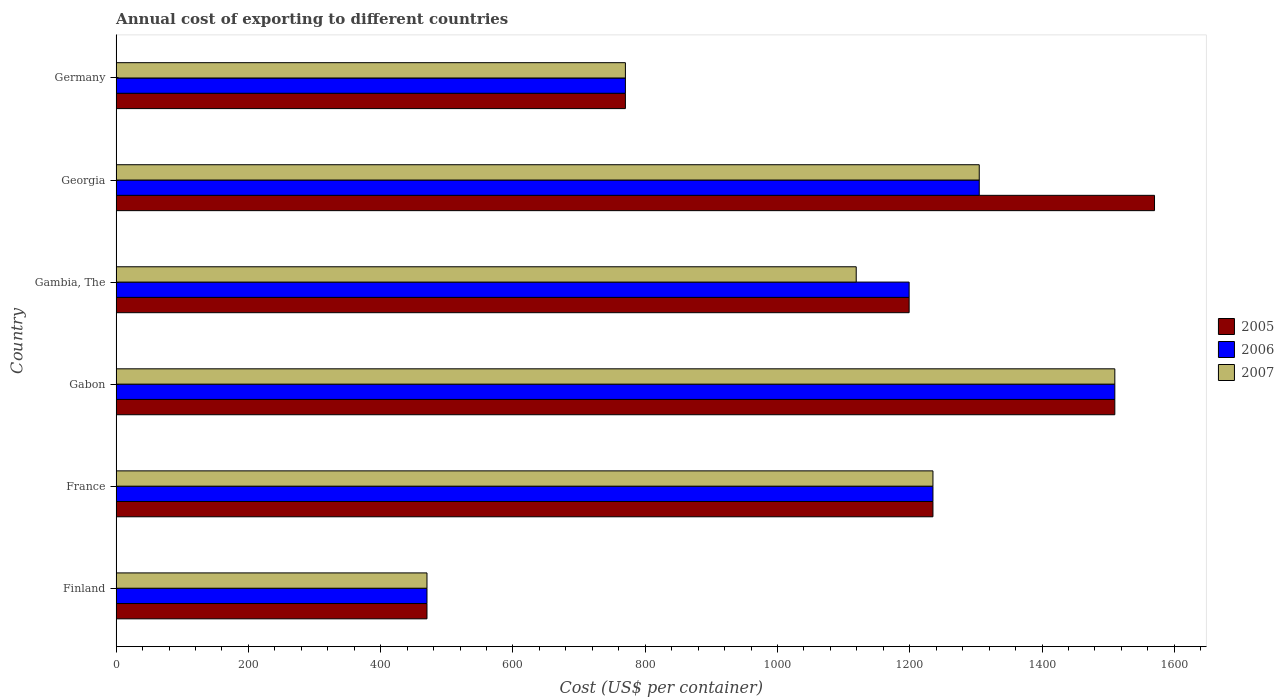How many groups of bars are there?
Give a very brief answer. 6. What is the label of the 2nd group of bars from the top?
Your answer should be very brief. Georgia. What is the total annual cost of exporting in 2005 in Gabon?
Offer a very short reply. 1510. Across all countries, what is the maximum total annual cost of exporting in 2006?
Your answer should be very brief. 1510. Across all countries, what is the minimum total annual cost of exporting in 2007?
Provide a succinct answer. 470. In which country was the total annual cost of exporting in 2007 maximum?
Make the answer very short. Gabon. What is the total total annual cost of exporting in 2007 in the graph?
Provide a short and direct response. 6409. What is the difference between the total annual cost of exporting in 2007 in Gabon and that in Georgia?
Give a very brief answer. 205. What is the difference between the total annual cost of exporting in 2005 in Gambia, The and the total annual cost of exporting in 2006 in Germany?
Your answer should be very brief. 429. What is the average total annual cost of exporting in 2007 per country?
Provide a short and direct response. 1068.17. What is the difference between the total annual cost of exporting in 2007 and total annual cost of exporting in 2006 in Germany?
Give a very brief answer. 0. What is the ratio of the total annual cost of exporting in 2007 in France to that in Germany?
Keep it short and to the point. 1.6. Is the total annual cost of exporting in 2007 in Gabon less than that in Germany?
Offer a very short reply. No. What is the difference between the highest and the second highest total annual cost of exporting in 2006?
Your answer should be very brief. 205. What is the difference between the highest and the lowest total annual cost of exporting in 2007?
Keep it short and to the point. 1040. Is the sum of the total annual cost of exporting in 2007 in France and Georgia greater than the maximum total annual cost of exporting in 2006 across all countries?
Offer a terse response. Yes. What does the 1st bar from the top in Finland represents?
Give a very brief answer. 2007. How many bars are there?
Provide a succinct answer. 18. Are all the bars in the graph horizontal?
Give a very brief answer. Yes. Are the values on the major ticks of X-axis written in scientific E-notation?
Keep it short and to the point. No. Does the graph contain any zero values?
Provide a short and direct response. No. How many legend labels are there?
Give a very brief answer. 3. What is the title of the graph?
Provide a succinct answer. Annual cost of exporting to different countries. What is the label or title of the X-axis?
Ensure brevity in your answer.  Cost (US$ per container). What is the label or title of the Y-axis?
Offer a terse response. Country. What is the Cost (US$ per container) of 2005 in Finland?
Keep it short and to the point. 470. What is the Cost (US$ per container) of 2006 in Finland?
Make the answer very short. 470. What is the Cost (US$ per container) of 2007 in Finland?
Ensure brevity in your answer.  470. What is the Cost (US$ per container) of 2005 in France?
Your answer should be compact. 1235. What is the Cost (US$ per container) of 2006 in France?
Provide a succinct answer. 1235. What is the Cost (US$ per container) of 2007 in France?
Offer a very short reply. 1235. What is the Cost (US$ per container) of 2005 in Gabon?
Your answer should be very brief. 1510. What is the Cost (US$ per container) of 2006 in Gabon?
Your answer should be compact. 1510. What is the Cost (US$ per container) of 2007 in Gabon?
Offer a terse response. 1510. What is the Cost (US$ per container) in 2005 in Gambia, The?
Offer a terse response. 1199. What is the Cost (US$ per container) in 2006 in Gambia, The?
Ensure brevity in your answer.  1199. What is the Cost (US$ per container) of 2007 in Gambia, The?
Your response must be concise. 1119. What is the Cost (US$ per container) in 2005 in Georgia?
Offer a terse response. 1570. What is the Cost (US$ per container) in 2006 in Georgia?
Offer a terse response. 1305. What is the Cost (US$ per container) of 2007 in Georgia?
Keep it short and to the point. 1305. What is the Cost (US$ per container) of 2005 in Germany?
Provide a short and direct response. 770. What is the Cost (US$ per container) of 2006 in Germany?
Your answer should be compact. 770. What is the Cost (US$ per container) in 2007 in Germany?
Your answer should be very brief. 770. Across all countries, what is the maximum Cost (US$ per container) in 2005?
Ensure brevity in your answer.  1570. Across all countries, what is the maximum Cost (US$ per container) of 2006?
Keep it short and to the point. 1510. Across all countries, what is the maximum Cost (US$ per container) in 2007?
Make the answer very short. 1510. Across all countries, what is the minimum Cost (US$ per container) in 2005?
Make the answer very short. 470. Across all countries, what is the minimum Cost (US$ per container) of 2006?
Your response must be concise. 470. Across all countries, what is the minimum Cost (US$ per container) of 2007?
Your answer should be very brief. 470. What is the total Cost (US$ per container) in 2005 in the graph?
Offer a terse response. 6754. What is the total Cost (US$ per container) of 2006 in the graph?
Ensure brevity in your answer.  6489. What is the total Cost (US$ per container) of 2007 in the graph?
Ensure brevity in your answer.  6409. What is the difference between the Cost (US$ per container) in 2005 in Finland and that in France?
Your response must be concise. -765. What is the difference between the Cost (US$ per container) in 2006 in Finland and that in France?
Make the answer very short. -765. What is the difference between the Cost (US$ per container) of 2007 in Finland and that in France?
Offer a very short reply. -765. What is the difference between the Cost (US$ per container) in 2005 in Finland and that in Gabon?
Provide a short and direct response. -1040. What is the difference between the Cost (US$ per container) of 2006 in Finland and that in Gabon?
Offer a terse response. -1040. What is the difference between the Cost (US$ per container) of 2007 in Finland and that in Gabon?
Keep it short and to the point. -1040. What is the difference between the Cost (US$ per container) of 2005 in Finland and that in Gambia, The?
Offer a very short reply. -729. What is the difference between the Cost (US$ per container) of 2006 in Finland and that in Gambia, The?
Your answer should be compact. -729. What is the difference between the Cost (US$ per container) in 2007 in Finland and that in Gambia, The?
Provide a succinct answer. -649. What is the difference between the Cost (US$ per container) in 2005 in Finland and that in Georgia?
Give a very brief answer. -1100. What is the difference between the Cost (US$ per container) of 2006 in Finland and that in Georgia?
Provide a short and direct response. -835. What is the difference between the Cost (US$ per container) in 2007 in Finland and that in Georgia?
Your response must be concise. -835. What is the difference between the Cost (US$ per container) of 2005 in Finland and that in Germany?
Your answer should be compact. -300. What is the difference between the Cost (US$ per container) of 2006 in Finland and that in Germany?
Give a very brief answer. -300. What is the difference between the Cost (US$ per container) in 2007 in Finland and that in Germany?
Give a very brief answer. -300. What is the difference between the Cost (US$ per container) in 2005 in France and that in Gabon?
Ensure brevity in your answer.  -275. What is the difference between the Cost (US$ per container) of 2006 in France and that in Gabon?
Your answer should be very brief. -275. What is the difference between the Cost (US$ per container) of 2007 in France and that in Gabon?
Give a very brief answer. -275. What is the difference between the Cost (US$ per container) in 2006 in France and that in Gambia, The?
Your answer should be very brief. 36. What is the difference between the Cost (US$ per container) in 2007 in France and that in Gambia, The?
Give a very brief answer. 116. What is the difference between the Cost (US$ per container) in 2005 in France and that in Georgia?
Offer a terse response. -335. What is the difference between the Cost (US$ per container) of 2006 in France and that in Georgia?
Make the answer very short. -70. What is the difference between the Cost (US$ per container) in 2007 in France and that in Georgia?
Your answer should be very brief. -70. What is the difference between the Cost (US$ per container) in 2005 in France and that in Germany?
Offer a terse response. 465. What is the difference between the Cost (US$ per container) in 2006 in France and that in Germany?
Your answer should be compact. 465. What is the difference between the Cost (US$ per container) of 2007 in France and that in Germany?
Ensure brevity in your answer.  465. What is the difference between the Cost (US$ per container) in 2005 in Gabon and that in Gambia, The?
Make the answer very short. 311. What is the difference between the Cost (US$ per container) in 2006 in Gabon and that in Gambia, The?
Your answer should be very brief. 311. What is the difference between the Cost (US$ per container) in 2007 in Gabon and that in Gambia, The?
Your answer should be very brief. 391. What is the difference between the Cost (US$ per container) in 2005 in Gabon and that in Georgia?
Provide a succinct answer. -60. What is the difference between the Cost (US$ per container) of 2006 in Gabon and that in Georgia?
Provide a short and direct response. 205. What is the difference between the Cost (US$ per container) of 2007 in Gabon and that in Georgia?
Offer a terse response. 205. What is the difference between the Cost (US$ per container) of 2005 in Gabon and that in Germany?
Your answer should be very brief. 740. What is the difference between the Cost (US$ per container) of 2006 in Gabon and that in Germany?
Give a very brief answer. 740. What is the difference between the Cost (US$ per container) in 2007 in Gabon and that in Germany?
Your answer should be very brief. 740. What is the difference between the Cost (US$ per container) in 2005 in Gambia, The and that in Georgia?
Ensure brevity in your answer.  -371. What is the difference between the Cost (US$ per container) of 2006 in Gambia, The and that in Georgia?
Give a very brief answer. -106. What is the difference between the Cost (US$ per container) of 2007 in Gambia, The and that in Georgia?
Provide a succinct answer. -186. What is the difference between the Cost (US$ per container) in 2005 in Gambia, The and that in Germany?
Offer a very short reply. 429. What is the difference between the Cost (US$ per container) of 2006 in Gambia, The and that in Germany?
Your response must be concise. 429. What is the difference between the Cost (US$ per container) of 2007 in Gambia, The and that in Germany?
Give a very brief answer. 349. What is the difference between the Cost (US$ per container) in 2005 in Georgia and that in Germany?
Keep it short and to the point. 800. What is the difference between the Cost (US$ per container) in 2006 in Georgia and that in Germany?
Keep it short and to the point. 535. What is the difference between the Cost (US$ per container) of 2007 in Georgia and that in Germany?
Offer a very short reply. 535. What is the difference between the Cost (US$ per container) in 2005 in Finland and the Cost (US$ per container) in 2006 in France?
Your answer should be very brief. -765. What is the difference between the Cost (US$ per container) in 2005 in Finland and the Cost (US$ per container) in 2007 in France?
Give a very brief answer. -765. What is the difference between the Cost (US$ per container) of 2006 in Finland and the Cost (US$ per container) of 2007 in France?
Give a very brief answer. -765. What is the difference between the Cost (US$ per container) in 2005 in Finland and the Cost (US$ per container) in 2006 in Gabon?
Provide a succinct answer. -1040. What is the difference between the Cost (US$ per container) in 2005 in Finland and the Cost (US$ per container) in 2007 in Gabon?
Your answer should be compact. -1040. What is the difference between the Cost (US$ per container) of 2006 in Finland and the Cost (US$ per container) of 2007 in Gabon?
Provide a succinct answer. -1040. What is the difference between the Cost (US$ per container) of 2005 in Finland and the Cost (US$ per container) of 2006 in Gambia, The?
Provide a succinct answer. -729. What is the difference between the Cost (US$ per container) in 2005 in Finland and the Cost (US$ per container) in 2007 in Gambia, The?
Your answer should be very brief. -649. What is the difference between the Cost (US$ per container) of 2006 in Finland and the Cost (US$ per container) of 2007 in Gambia, The?
Give a very brief answer. -649. What is the difference between the Cost (US$ per container) in 2005 in Finland and the Cost (US$ per container) in 2006 in Georgia?
Your answer should be very brief. -835. What is the difference between the Cost (US$ per container) of 2005 in Finland and the Cost (US$ per container) of 2007 in Georgia?
Offer a very short reply. -835. What is the difference between the Cost (US$ per container) in 2006 in Finland and the Cost (US$ per container) in 2007 in Georgia?
Ensure brevity in your answer.  -835. What is the difference between the Cost (US$ per container) in 2005 in Finland and the Cost (US$ per container) in 2006 in Germany?
Provide a short and direct response. -300. What is the difference between the Cost (US$ per container) of 2005 in Finland and the Cost (US$ per container) of 2007 in Germany?
Your answer should be very brief. -300. What is the difference between the Cost (US$ per container) in 2006 in Finland and the Cost (US$ per container) in 2007 in Germany?
Your answer should be compact. -300. What is the difference between the Cost (US$ per container) in 2005 in France and the Cost (US$ per container) in 2006 in Gabon?
Provide a succinct answer. -275. What is the difference between the Cost (US$ per container) in 2005 in France and the Cost (US$ per container) in 2007 in Gabon?
Make the answer very short. -275. What is the difference between the Cost (US$ per container) of 2006 in France and the Cost (US$ per container) of 2007 in Gabon?
Give a very brief answer. -275. What is the difference between the Cost (US$ per container) of 2005 in France and the Cost (US$ per container) of 2006 in Gambia, The?
Give a very brief answer. 36. What is the difference between the Cost (US$ per container) of 2005 in France and the Cost (US$ per container) of 2007 in Gambia, The?
Provide a succinct answer. 116. What is the difference between the Cost (US$ per container) of 2006 in France and the Cost (US$ per container) of 2007 in Gambia, The?
Offer a very short reply. 116. What is the difference between the Cost (US$ per container) in 2005 in France and the Cost (US$ per container) in 2006 in Georgia?
Provide a succinct answer. -70. What is the difference between the Cost (US$ per container) in 2005 in France and the Cost (US$ per container) in 2007 in Georgia?
Your response must be concise. -70. What is the difference between the Cost (US$ per container) in 2006 in France and the Cost (US$ per container) in 2007 in Georgia?
Ensure brevity in your answer.  -70. What is the difference between the Cost (US$ per container) of 2005 in France and the Cost (US$ per container) of 2006 in Germany?
Provide a short and direct response. 465. What is the difference between the Cost (US$ per container) of 2005 in France and the Cost (US$ per container) of 2007 in Germany?
Give a very brief answer. 465. What is the difference between the Cost (US$ per container) in 2006 in France and the Cost (US$ per container) in 2007 in Germany?
Keep it short and to the point. 465. What is the difference between the Cost (US$ per container) in 2005 in Gabon and the Cost (US$ per container) in 2006 in Gambia, The?
Give a very brief answer. 311. What is the difference between the Cost (US$ per container) of 2005 in Gabon and the Cost (US$ per container) of 2007 in Gambia, The?
Your answer should be compact. 391. What is the difference between the Cost (US$ per container) in 2006 in Gabon and the Cost (US$ per container) in 2007 in Gambia, The?
Offer a terse response. 391. What is the difference between the Cost (US$ per container) of 2005 in Gabon and the Cost (US$ per container) of 2006 in Georgia?
Offer a terse response. 205. What is the difference between the Cost (US$ per container) in 2005 in Gabon and the Cost (US$ per container) in 2007 in Georgia?
Your answer should be very brief. 205. What is the difference between the Cost (US$ per container) in 2006 in Gabon and the Cost (US$ per container) in 2007 in Georgia?
Your answer should be compact. 205. What is the difference between the Cost (US$ per container) of 2005 in Gabon and the Cost (US$ per container) of 2006 in Germany?
Keep it short and to the point. 740. What is the difference between the Cost (US$ per container) in 2005 in Gabon and the Cost (US$ per container) in 2007 in Germany?
Your response must be concise. 740. What is the difference between the Cost (US$ per container) in 2006 in Gabon and the Cost (US$ per container) in 2007 in Germany?
Your answer should be compact. 740. What is the difference between the Cost (US$ per container) in 2005 in Gambia, The and the Cost (US$ per container) in 2006 in Georgia?
Keep it short and to the point. -106. What is the difference between the Cost (US$ per container) in 2005 in Gambia, The and the Cost (US$ per container) in 2007 in Georgia?
Ensure brevity in your answer.  -106. What is the difference between the Cost (US$ per container) of 2006 in Gambia, The and the Cost (US$ per container) of 2007 in Georgia?
Give a very brief answer. -106. What is the difference between the Cost (US$ per container) of 2005 in Gambia, The and the Cost (US$ per container) of 2006 in Germany?
Offer a terse response. 429. What is the difference between the Cost (US$ per container) in 2005 in Gambia, The and the Cost (US$ per container) in 2007 in Germany?
Keep it short and to the point. 429. What is the difference between the Cost (US$ per container) in 2006 in Gambia, The and the Cost (US$ per container) in 2007 in Germany?
Your answer should be compact. 429. What is the difference between the Cost (US$ per container) of 2005 in Georgia and the Cost (US$ per container) of 2006 in Germany?
Offer a terse response. 800. What is the difference between the Cost (US$ per container) in 2005 in Georgia and the Cost (US$ per container) in 2007 in Germany?
Offer a very short reply. 800. What is the difference between the Cost (US$ per container) of 2006 in Georgia and the Cost (US$ per container) of 2007 in Germany?
Ensure brevity in your answer.  535. What is the average Cost (US$ per container) in 2005 per country?
Provide a succinct answer. 1125.67. What is the average Cost (US$ per container) in 2006 per country?
Your answer should be compact. 1081.5. What is the average Cost (US$ per container) in 2007 per country?
Ensure brevity in your answer.  1068.17. What is the difference between the Cost (US$ per container) in 2005 and Cost (US$ per container) in 2006 in Finland?
Give a very brief answer. 0. What is the difference between the Cost (US$ per container) of 2005 and Cost (US$ per container) of 2007 in Finland?
Provide a short and direct response. 0. What is the difference between the Cost (US$ per container) of 2005 and Cost (US$ per container) of 2006 in France?
Provide a short and direct response. 0. What is the difference between the Cost (US$ per container) in 2005 and Cost (US$ per container) in 2007 in Gabon?
Provide a short and direct response. 0. What is the difference between the Cost (US$ per container) of 2006 and Cost (US$ per container) of 2007 in Gabon?
Offer a very short reply. 0. What is the difference between the Cost (US$ per container) in 2005 and Cost (US$ per container) in 2006 in Gambia, The?
Offer a very short reply. 0. What is the difference between the Cost (US$ per container) in 2006 and Cost (US$ per container) in 2007 in Gambia, The?
Ensure brevity in your answer.  80. What is the difference between the Cost (US$ per container) in 2005 and Cost (US$ per container) in 2006 in Georgia?
Your response must be concise. 265. What is the difference between the Cost (US$ per container) of 2005 and Cost (US$ per container) of 2007 in Georgia?
Offer a terse response. 265. What is the difference between the Cost (US$ per container) of 2006 and Cost (US$ per container) of 2007 in Georgia?
Provide a succinct answer. 0. What is the difference between the Cost (US$ per container) in 2005 and Cost (US$ per container) in 2006 in Germany?
Make the answer very short. 0. What is the difference between the Cost (US$ per container) in 2005 and Cost (US$ per container) in 2007 in Germany?
Offer a terse response. 0. What is the ratio of the Cost (US$ per container) in 2005 in Finland to that in France?
Your answer should be compact. 0.38. What is the ratio of the Cost (US$ per container) in 2006 in Finland to that in France?
Your response must be concise. 0.38. What is the ratio of the Cost (US$ per container) in 2007 in Finland to that in France?
Offer a terse response. 0.38. What is the ratio of the Cost (US$ per container) in 2005 in Finland to that in Gabon?
Keep it short and to the point. 0.31. What is the ratio of the Cost (US$ per container) of 2006 in Finland to that in Gabon?
Your answer should be compact. 0.31. What is the ratio of the Cost (US$ per container) in 2007 in Finland to that in Gabon?
Provide a short and direct response. 0.31. What is the ratio of the Cost (US$ per container) of 2005 in Finland to that in Gambia, The?
Provide a succinct answer. 0.39. What is the ratio of the Cost (US$ per container) in 2006 in Finland to that in Gambia, The?
Offer a terse response. 0.39. What is the ratio of the Cost (US$ per container) in 2007 in Finland to that in Gambia, The?
Provide a short and direct response. 0.42. What is the ratio of the Cost (US$ per container) of 2005 in Finland to that in Georgia?
Your answer should be compact. 0.3. What is the ratio of the Cost (US$ per container) in 2006 in Finland to that in Georgia?
Give a very brief answer. 0.36. What is the ratio of the Cost (US$ per container) of 2007 in Finland to that in Georgia?
Keep it short and to the point. 0.36. What is the ratio of the Cost (US$ per container) of 2005 in Finland to that in Germany?
Keep it short and to the point. 0.61. What is the ratio of the Cost (US$ per container) of 2006 in Finland to that in Germany?
Your response must be concise. 0.61. What is the ratio of the Cost (US$ per container) of 2007 in Finland to that in Germany?
Provide a succinct answer. 0.61. What is the ratio of the Cost (US$ per container) of 2005 in France to that in Gabon?
Keep it short and to the point. 0.82. What is the ratio of the Cost (US$ per container) of 2006 in France to that in Gabon?
Your answer should be compact. 0.82. What is the ratio of the Cost (US$ per container) in 2007 in France to that in Gabon?
Ensure brevity in your answer.  0.82. What is the ratio of the Cost (US$ per container) of 2007 in France to that in Gambia, The?
Offer a very short reply. 1.1. What is the ratio of the Cost (US$ per container) of 2005 in France to that in Georgia?
Your answer should be compact. 0.79. What is the ratio of the Cost (US$ per container) of 2006 in France to that in Georgia?
Offer a very short reply. 0.95. What is the ratio of the Cost (US$ per container) in 2007 in France to that in Georgia?
Ensure brevity in your answer.  0.95. What is the ratio of the Cost (US$ per container) in 2005 in France to that in Germany?
Give a very brief answer. 1.6. What is the ratio of the Cost (US$ per container) in 2006 in France to that in Germany?
Offer a very short reply. 1.6. What is the ratio of the Cost (US$ per container) in 2007 in France to that in Germany?
Keep it short and to the point. 1.6. What is the ratio of the Cost (US$ per container) in 2005 in Gabon to that in Gambia, The?
Ensure brevity in your answer.  1.26. What is the ratio of the Cost (US$ per container) of 2006 in Gabon to that in Gambia, The?
Your response must be concise. 1.26. What is the ratio of the Cost (US$ per container) of 2007 in Gabon to that in Gambia, The?
Your response must be concise. 1.35. What is the ratio of the Cost (US$ per container) of 2005 in Gabon to that in Georgia?
Provide a short and direct response. 0.96. What is the ratio of the Cost (US$ per container) of 2006 in Gabon to that in Georgia?
Your response must be concise. 1.16. What is the ratio of the Cost (US$ per container) of 2007 in Gabon to that in Georgia?
Give a very brief answer. 1.16. What is the ratio of the Cost (US$ per container) in 2005 in Gabon to that in Germany?
Make the answer very short. 1.96. What is the ratio of the Cost (US$ per container) of 2006 in Gabon to that in Germany?
Offer a very short reply. 1.96. What is the ratio of the Cost (US$ per container) in 2007 in Gabon to that in Germany?
Give a very brief answer. 1.96. What is the ratio of the Cost (US$ per container) of 2005 in Gambia, The to that in Georgia?
Provide a short and direct response. 0.76. What is the ratio of the Cost (US$ per container) of 2006 in Gambia, The to that in Georgia?
Your response must be concise. 0.92. What is the ratio of the Cost (US$ per container) in 2007 in Gambia, The to that in Georgia?
Your answer should be very brief. 0.86. What is the ratio of the Cost (US$ per container) of 2005 in Gambia, The to that in Germany?
Ensure brevity in your answer.  1.56. What is the ratio of the Cost (US$ per container) of 2006 in Gambia, The to that in Germany?
Your response must be concise. 1.56. What is the ratio of the Cost (US$ per container) of 2007 in Gambia, The to that in Germany?
Offer a very short reply. 1.45. What is the ratio of the Cost (US$ per container) in 2005 in Georgia to that in Germany?
Your answer should be very brief. 2.04. What is the ratio of the Cost (US$ per container) in 2006 in Georgia to that in Germany?
Provide a short and direct response. 1.69. What is the ratio of the Cost (US$ per container) in 2007 in Georgia to that in Germany?
Ensure brevity in your answer.  1.69. What is the difference between the highest and the second highest Cost (US$ per container) in 2006?
Offer a very short reply. 205. What is the difference between the highest and the second highest Cost (US$ per container) of 2007?
Keep it short and to the point. 205. What is the difference between the highest and the lowest Cost (US$ per container) in 2005?
Keep it short and to the point. 1100. What is the difference between the highest and the lowest Cost (US$ per container) of 2006?
Give a very brief answer. 1040. What is the difference between the highest and the lowest Cost (US$ per container) of 2007?
Your response must be concise. 1040. 